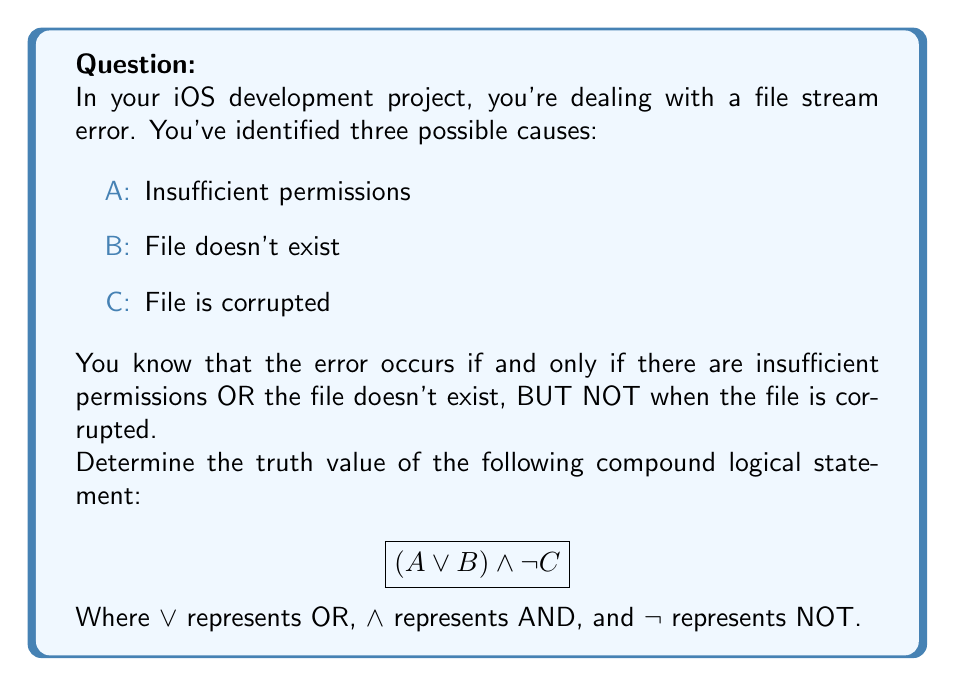Help me with this question. Let's approach this step-by-step:

1) First, we need to understand what the statement means:
   $$(A \lor B) \land \lnot C$$
   This can be read as "(A OR B) AND (NOT C)"

2) We're told that the error occurs if and only if there are insufficient permissions OR the file doesn't exist, BUT NOT when the file is corrupted. This directly corresponds to our logical statement.

3) Let's break it down:
   - $(A \lor B)$ is true when either A is true, B is true, or both are true.
   - $\lnot C$ is true when C is false.

4) For the entire statement to be true:
   - Either A or B (or both) must be true (representing insufficient permissions or file doesn't exist)
   - AND
   - C must be false (representing that the file is not corrupted)

5) This exactly matches the conditions given in the problem statement.

6) Therefore, this logical statement correctly represents the conditions under which the file stream error occurs.

7) Since the statement accurately describes the error condition, it is true.
Answer: True 